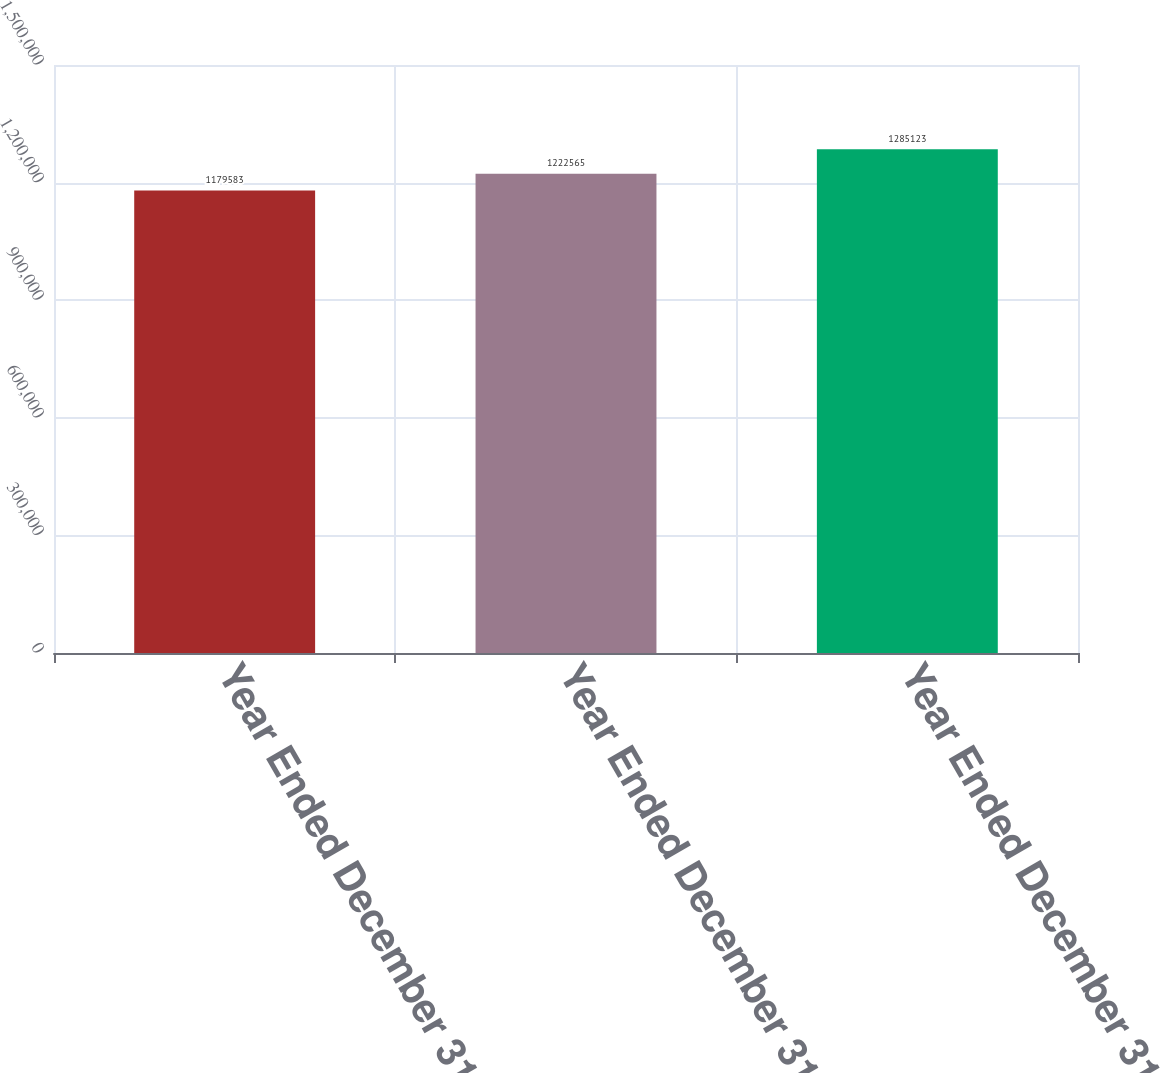Convert chart. <chart><loc_0><loc_0><loc_500><loc_500><bar_chart><fcel>Year Ended December 31 2009<fcel>Year Ended December 31 2008<fcel>Year Ended December 31 2007<nl><fcel>1.17958e+06<fcel>1.22256e+06<fcel>1.28512e+06<nl></chart> 